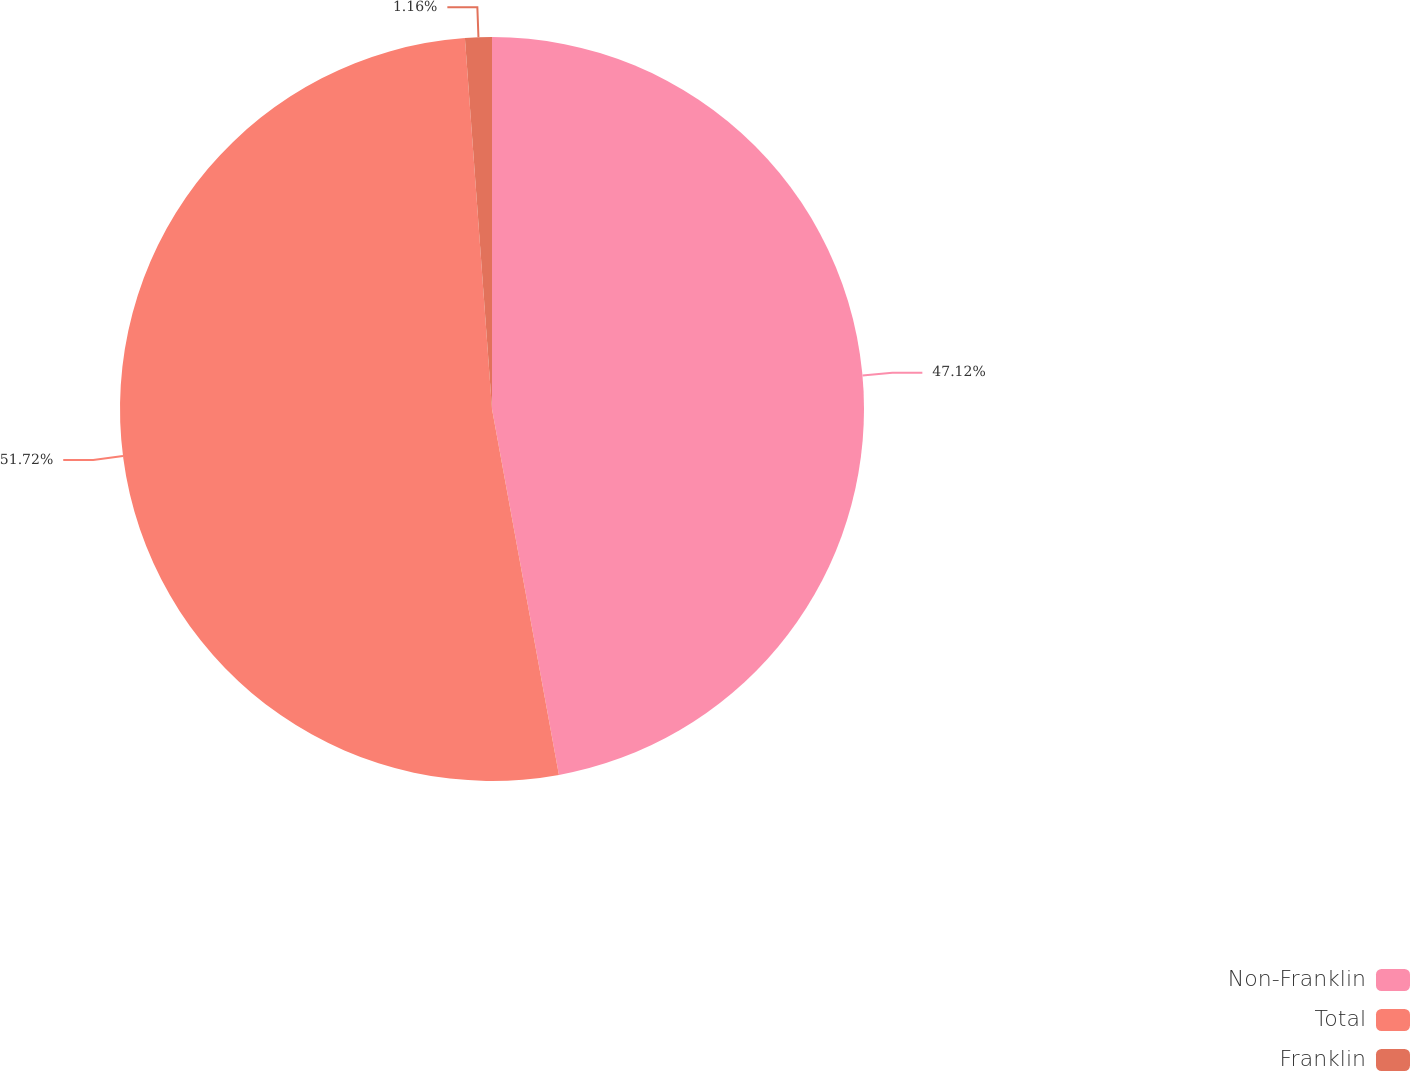Convert chart. <chart><loc_0><loc_0><loc_500><loc_500><pie_chart><fcel>Non-Franklin<fcel>Total<fcel>Franklin<nl><fcel>47.12%<fcel>51.72%<fcel>1.16%<nl></chart> 